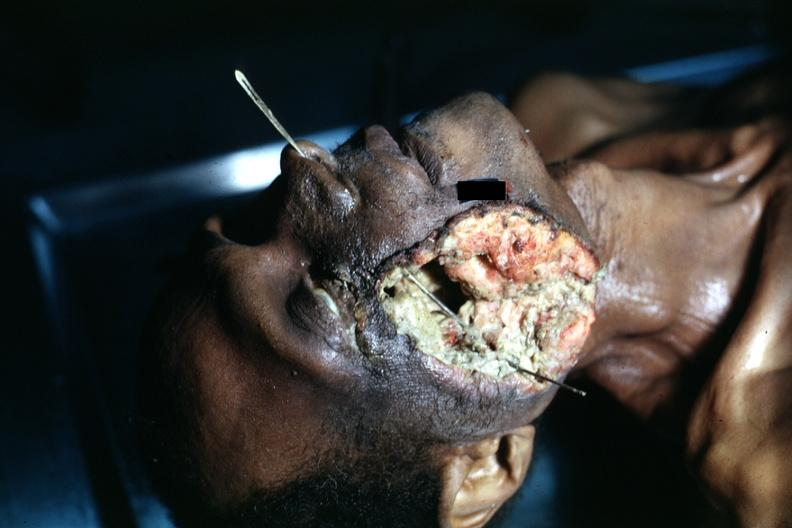s pus in test tube present?
Answer the question using a single word or phrase. No 